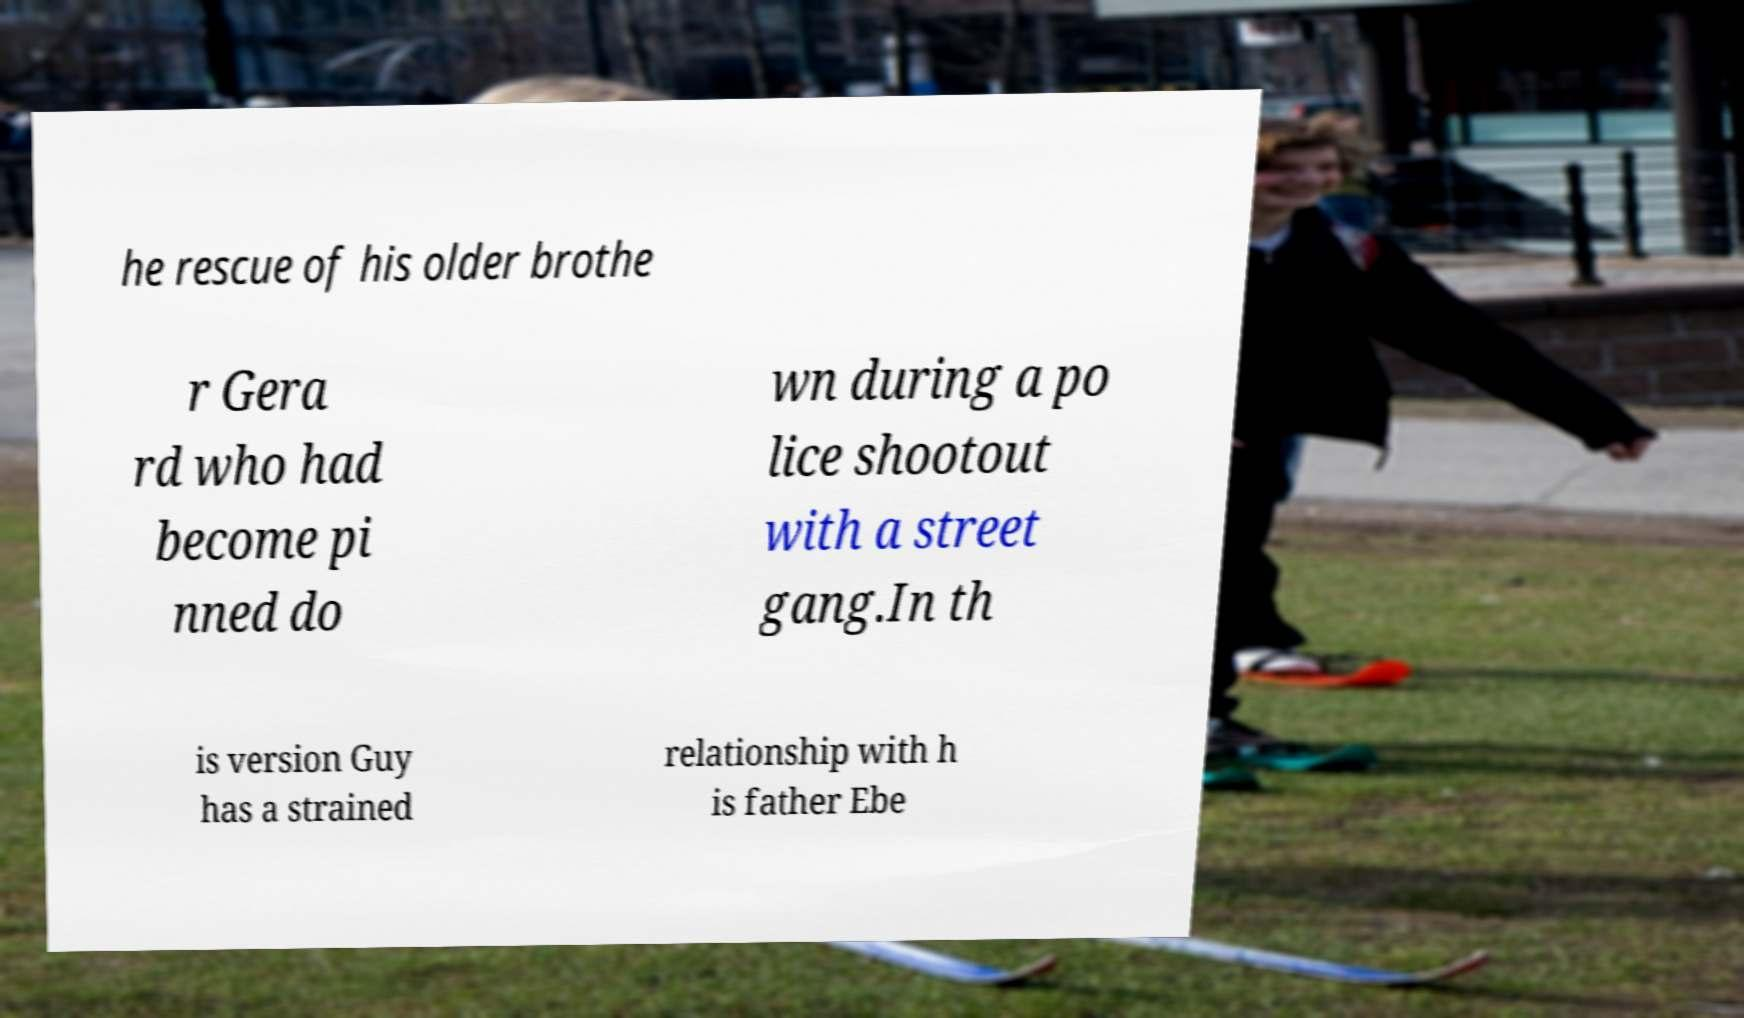Can you read and provide the text displayed in the image?This photo seems to have some interesting text. Can you extract and type it out for me? he rescue of his older brothe r Gera rd who had become pi nned do wn during a po lice shootout with a street gang.In th is version Guy has a strained relationship with h is father Ebe 